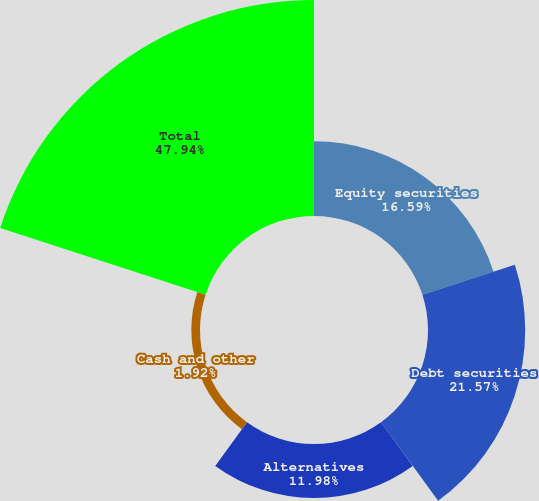<chart> <loc_0><loc_0><loc_500><loc_500><pie_chart><fcel>Equity securities<fcel>Debt securities<fcel>Alternatives<fcel>Cash and other<fcel>Total<nl><fcel>16.59%<fcel>21.57%<fcel>11.98%<fcel>1.92%<fcel>47.94%<nl></chart> 